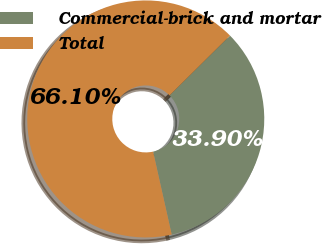Convert chart. <chart><loc_0><loc_0><loc_500><loc_500><pie_chart><fcel>Commercial-brick and mortar<fcel>Total<nl><fcel>33.9%<fcel>66.1%<nl></chart> 